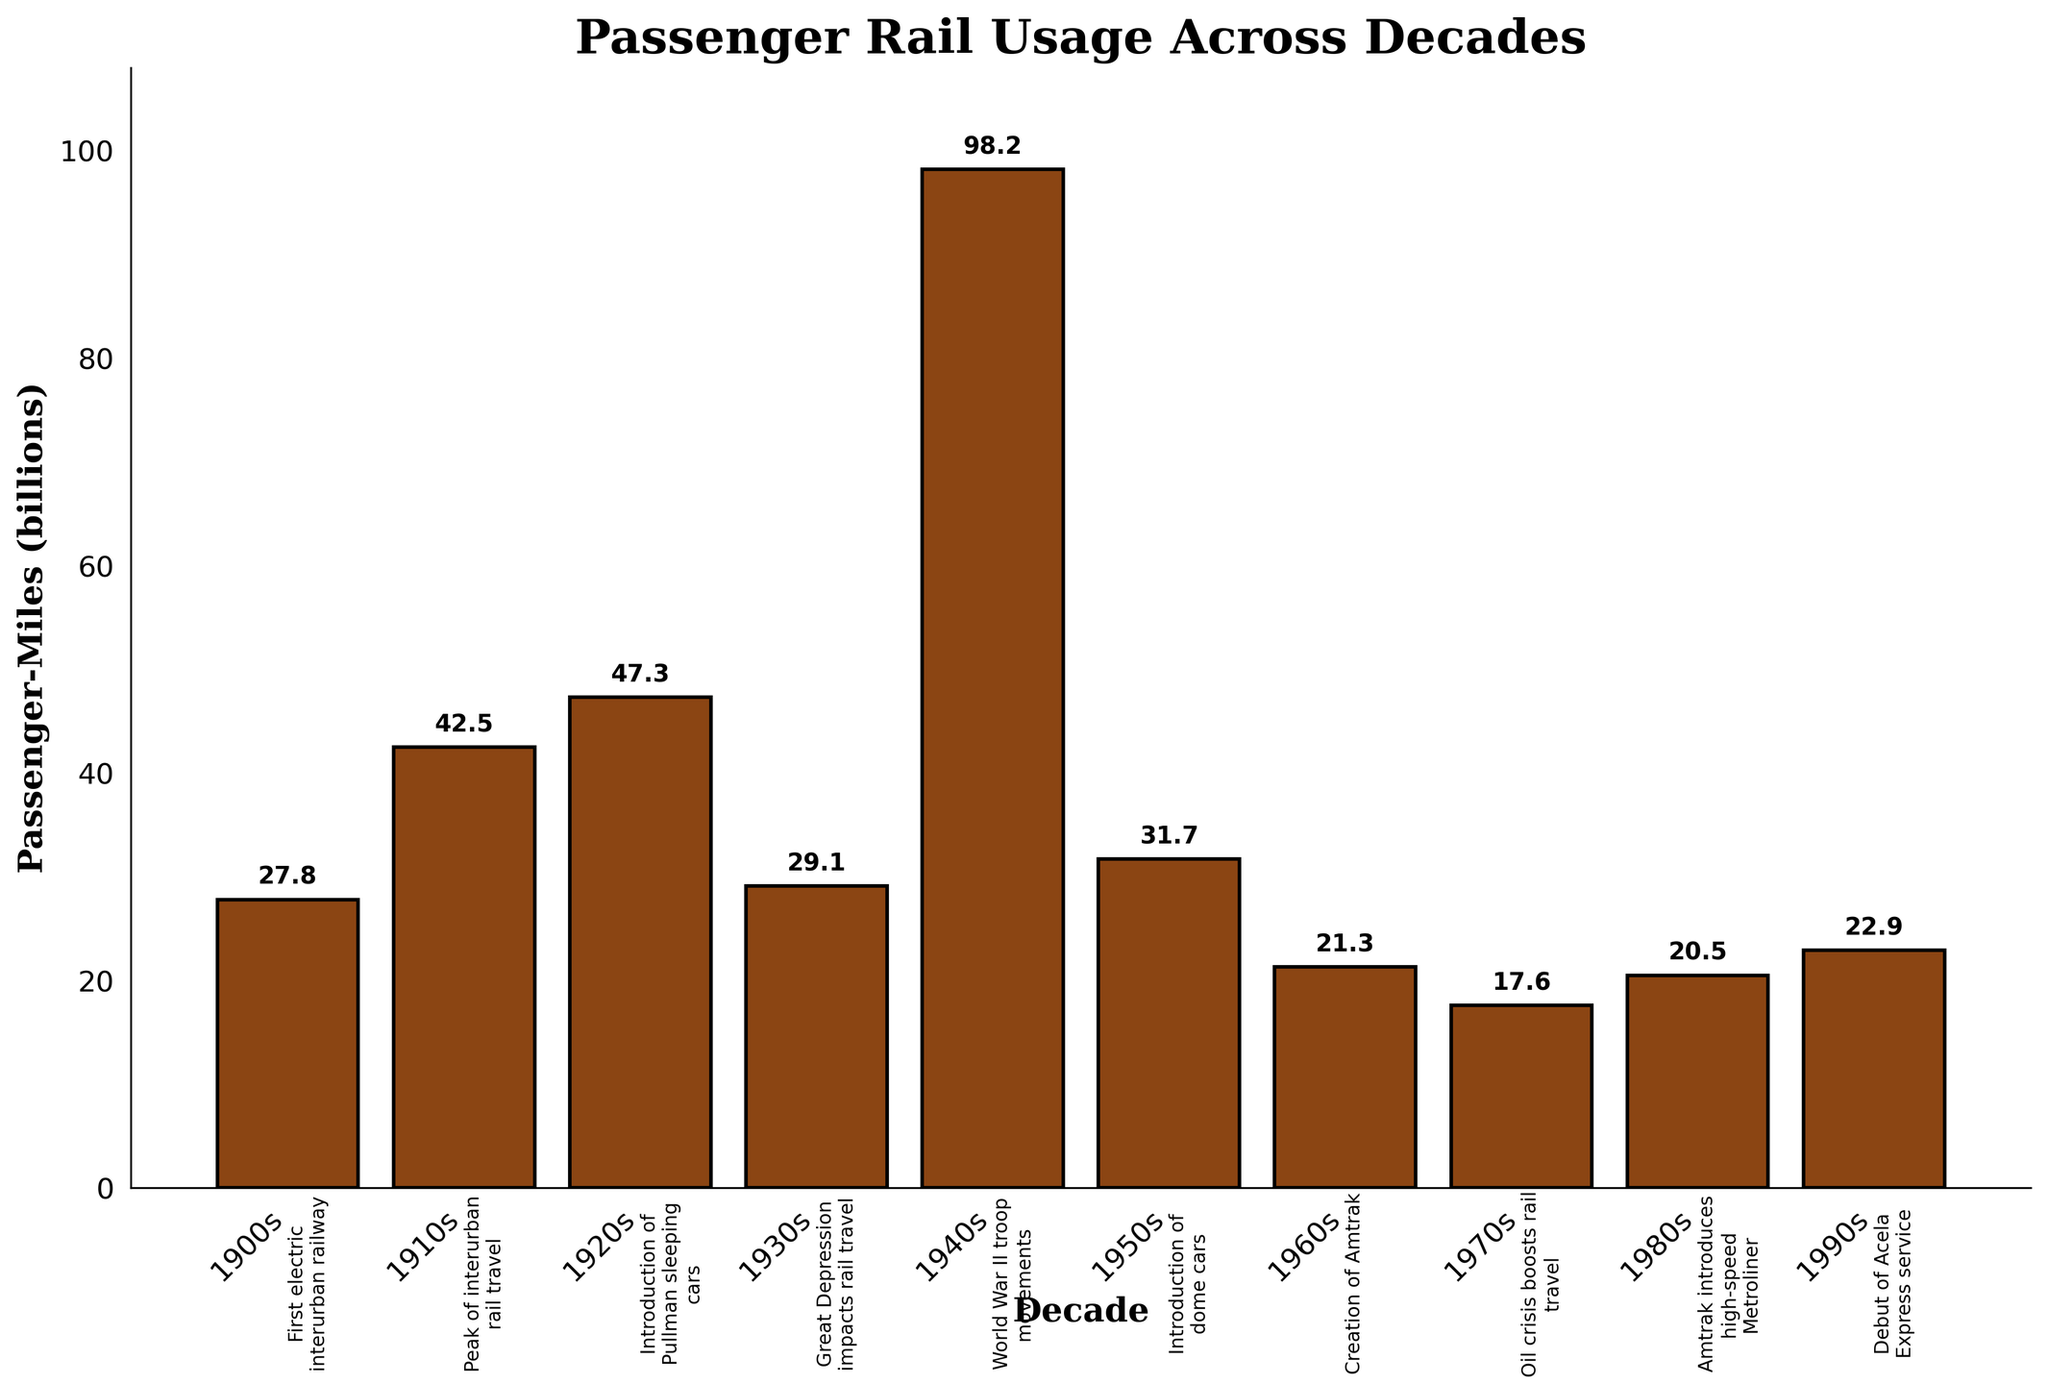What is the decade with the highest passenger-miles? First, look at the height of each bar in the bar chart. The tallest bar is what we are interested in. In this case, the tallest bar corresponds to the 1940s, which means it has the highest passenger-miles.
Answer: 1940s Which decade experienced a decline in passenger-miles compared to the previous decade? Look at the height of each bar and identify where a bar is shorter than the previous one. The bar chart shows that after the 1940s peak, the 1950s bar is significantly shorter, indicating a decline. Similarly, the 1960s also show a decline from the 1950s.
Answer: 1950s, 1960s What notable event is associated with the spike in passenger-miles during the 1940s? Look at the annotations above the bars to find the notable event. The bar for the 1940s, which has the highest value, is labeled with "World War II troop movements".
Answer: World War II troop movements Which decade had the lowest passenger-miles, and what event is associated with this period? Identify the shortest bar on the chart and refer to the annotation for that bar. The shortest bar is for the 1970s, which is associated with the "Oil crisis boosts rail travel" event.
Answer: 1970s, Oil crisis boosts rail travel How did passenger-miles change from the 1910s to the 1920s? Compare the heights of the bars for the 1910s and the 1920s. The bar for the 1920s is slightly taller than that for the 1910s, indicating an increase.
Answer: Increased What is the average passenger-miles between 1900s and 1950s? Sum the passenger-miles for each decade from 1900s to 1950s and then divide by the number of decades. (27.8 + 42.5 + 47.3 + 29.1 + 98.2 + 31.7) / 6 = 46.1 billion passenger-miles.
Answer: 46.1 billion How do passenger-miles in the 1990s compare to those in the 1960s? Compare the height of the bar for the 1990s to the bar for the 1960s. The bar for the 1990s is taller than that for the 1960s, indicating an increase in passenger-miles.
Answer: Increased 